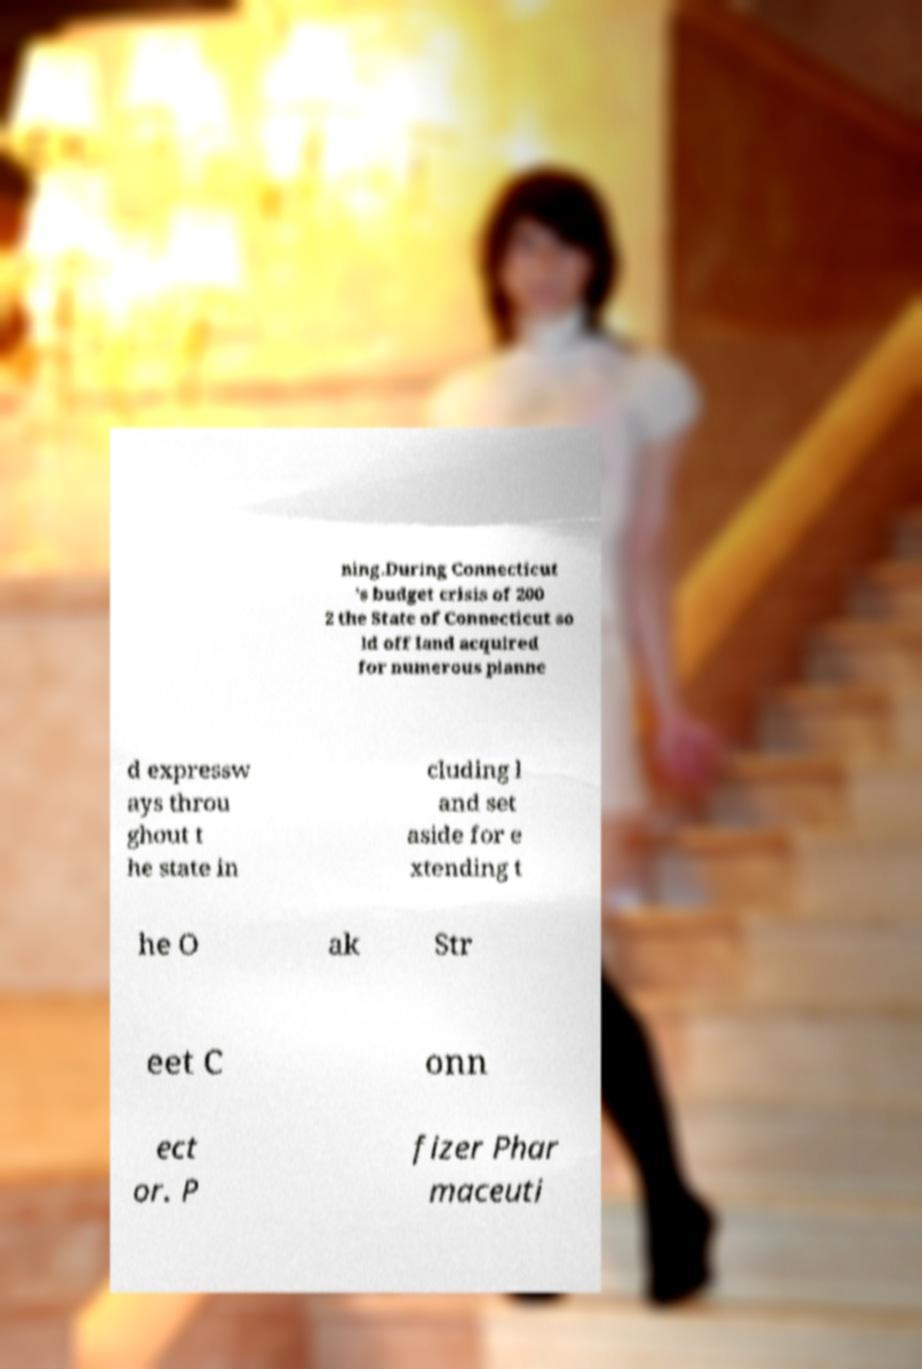I need the written content from this picture converted into text. Can you do that? ning.During Connecticut 's budget crisis of 200 2 the State of Connecticut so ld off land acquired for numerous planne d expressw ays throu ghout t he state in cluding l and set aside for e xtending t he O ak Str eet C onn ect or. P fizer Phar maceuti 